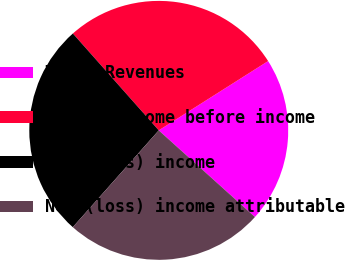Convert chart to OTSL. <chart><loc_0><loc_0><loc_500><loc_500><pie_chart><fcel>Total Revenues<fcel>(Loss) income before income<fcel>Net (loss) income<fcel>Net (loss) income attributable<nl><fcel>20.66%<fcel>27.56%<fcel>26.9%<fcel>24.89%<nl></chart> 